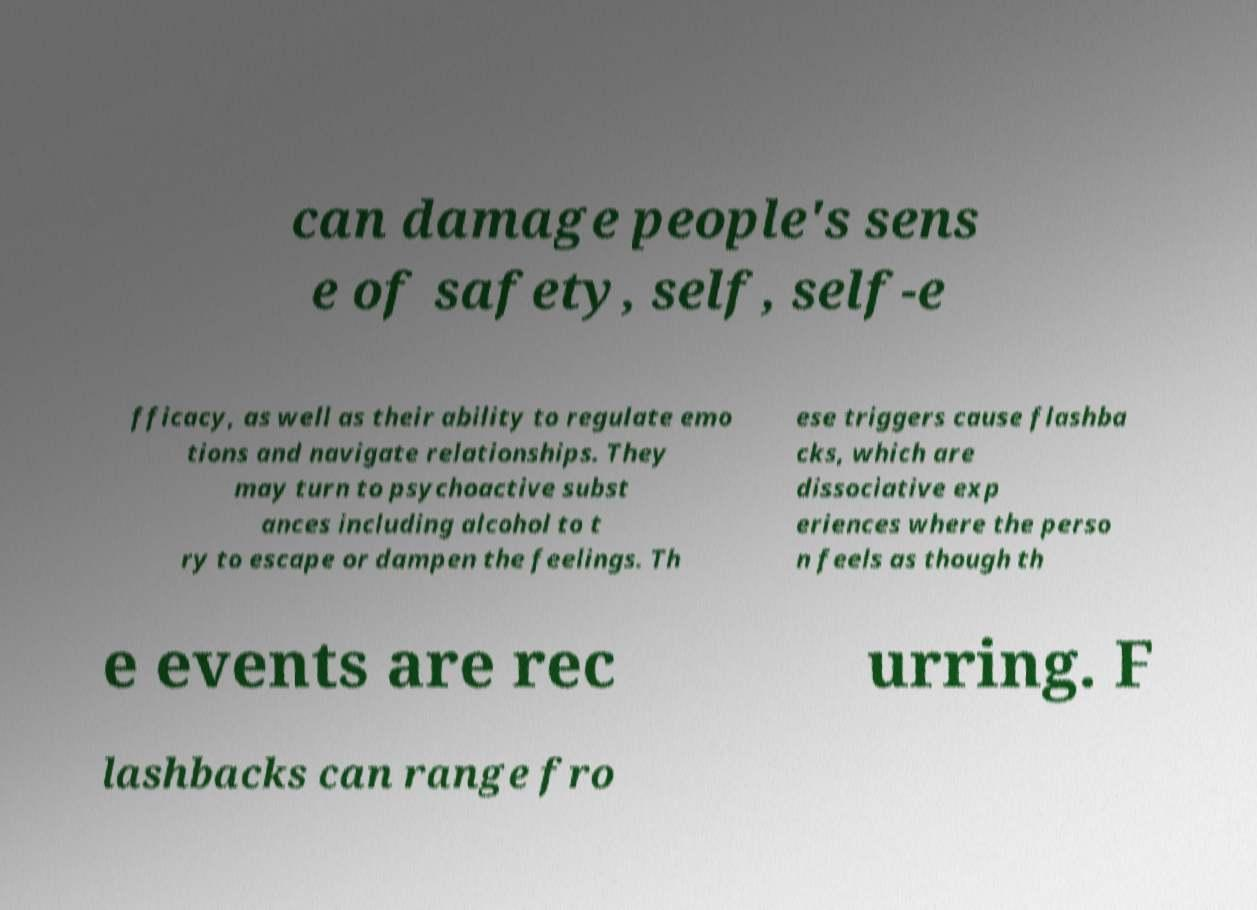There's text embedded in this image that I need extracted. Can you transcribe it verbatim? can damage people's sens e of safety, self, self-e fficacy, as well as their ability to regulate emo tions and navigate relationships. They may turn to psychoactive subst ances including alcohol to t ry to escape or dampen the feelings. Th ese triggers cause flashba cks, which are dissociative exp eriences where the perso n feels as though th e events are rec urring. F lashbacks can range fro 